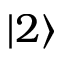Convert formula to latex. <formula><loc_0><loc_0><loc_500><loc_500>| 2 \rangle</formula> 